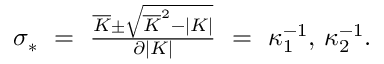<formula> <loc_0><loc_0><loc_500><loc_500>\begin{array} { r } { \sigma _ { * } \ = \ \frac { \overline { K } \pm \sqrt { \overline { K } ^ { 2 } - | K | } } { \partial | K | } \ = \ \kappa _ { 1 } ^ { - 1 } , \, \kappa _ { 2 } ^ { - 1 } . } \end{array}</formula> 